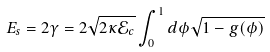Convert formula to latex. <formula><loc_0><loc_0><loc_500><loc_500>E _ { s } = 2 \gamma = 2 \sqrt { 2 \kappa \mathcal { E } _ { c } } \int _ { 0 } ^ { 1 } d \phi \sqrt { 1 - g ( \phi ) }</formula> 